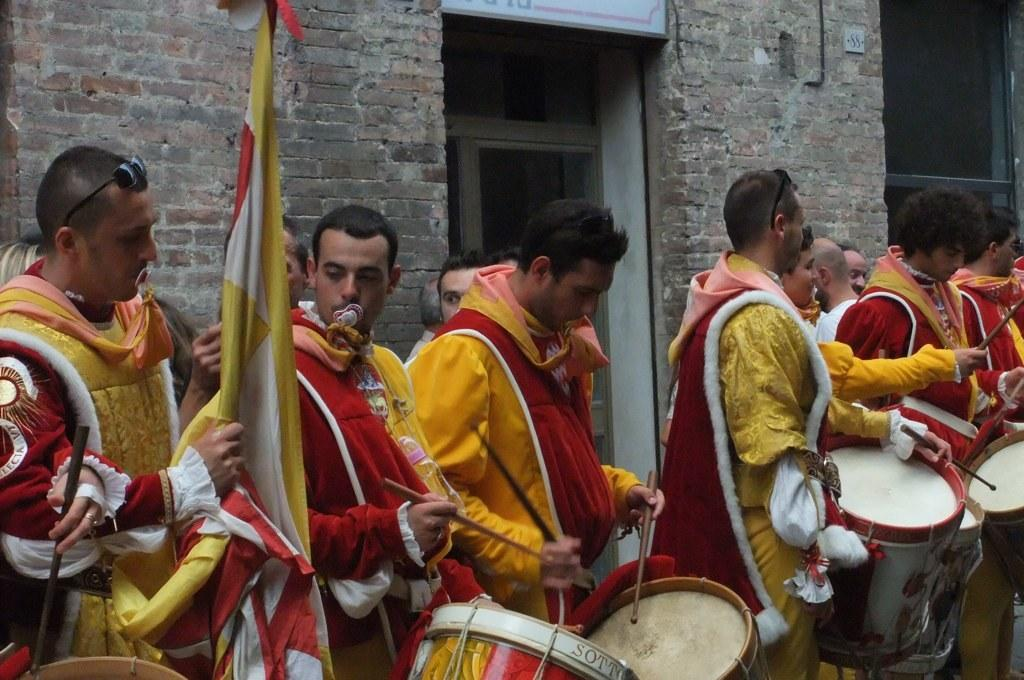How many people are in the image? There is a group of people in the image. What are some of the people doing in the image? Some people are playing drums. What can be seen in the background of the image? There is a wall visible in the background. What is the symbol or emblem in the image? There is a flag in the image. Where is the square table located in the image? There is no square table present in the image. What type of lunchroom can be seen in the image? There is no lunchroom present in the image. 